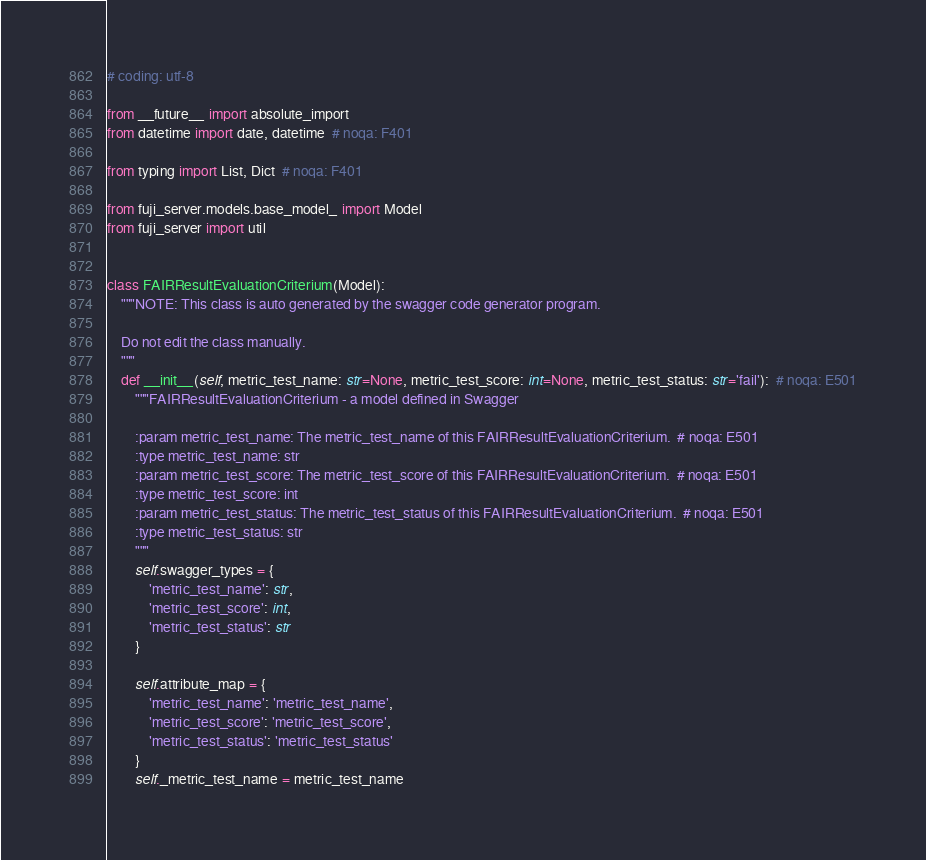Convert code to text. <code><loc_0><loc_0><loc_500><loc_500><_Python_># coding: utf-8

from __future__ import absolute_import
from datetime import date, datetime  # noqa: F401

from typing import List, Dict  # noqa: F401

from fuji_server.models.base_model_ import Model
from fuji_server import util


class FAIRResultEvaluationCriterium(Model):
    """NOTE: This class is auto generated by the swagger code generator program.

    Do not edit the class manually.
    """
    def __init__(self, metric_test_name: str=None, metric_test_score: int=None, metric_test_status: str='fail'):  # noqa: E501
        """FAIRResultEvaluationCriterium - a model defined in Swagger

        :param metric_test_name: The metric_test_name of this FAIRResultEvaluationCriterium.  # noqa: E501
        :type metric_test_name: str
        :param metric_test_score: The metric_test_score of this FAIRResultEvaluationCriterium.  # noqa: E501
        :type metric_test_score: int
        :param metric_test_status: The metric_test_status of this FAIRResultEvaluationCriterium.  # noqa: E501
        :type metric_test_status: str
        """
        self.swagger_types = {
            'metric_test_name': str,
            'metric_test_score': int,
            'metric_test_status': str
        }

        self.attribute_map = {
            'metric_test_name': 'metric_test_name',
            'metric_test_score': 'metric_test_score',
            'metric_test_status': 'metric_test_status'
        }
        self._metric_test_name = metric_test_name</code> 